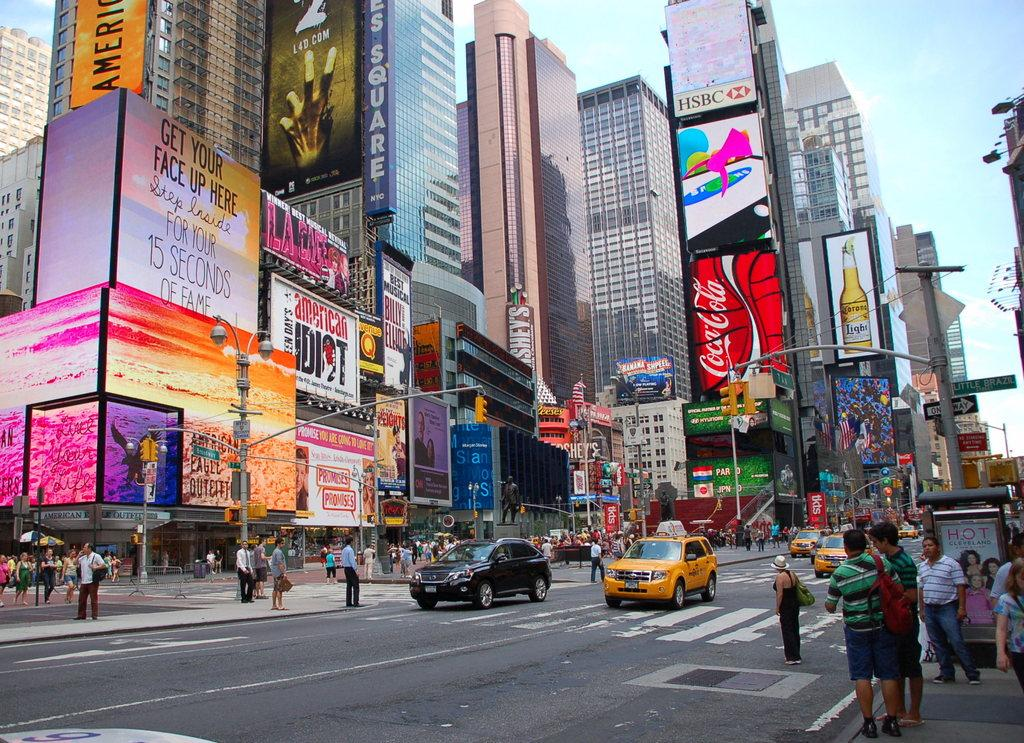<image>
Describe the image concisely. People and cars on a city street standing under electronic billboards with ads for everything from CocaCola to putting your own face up on the sign. 